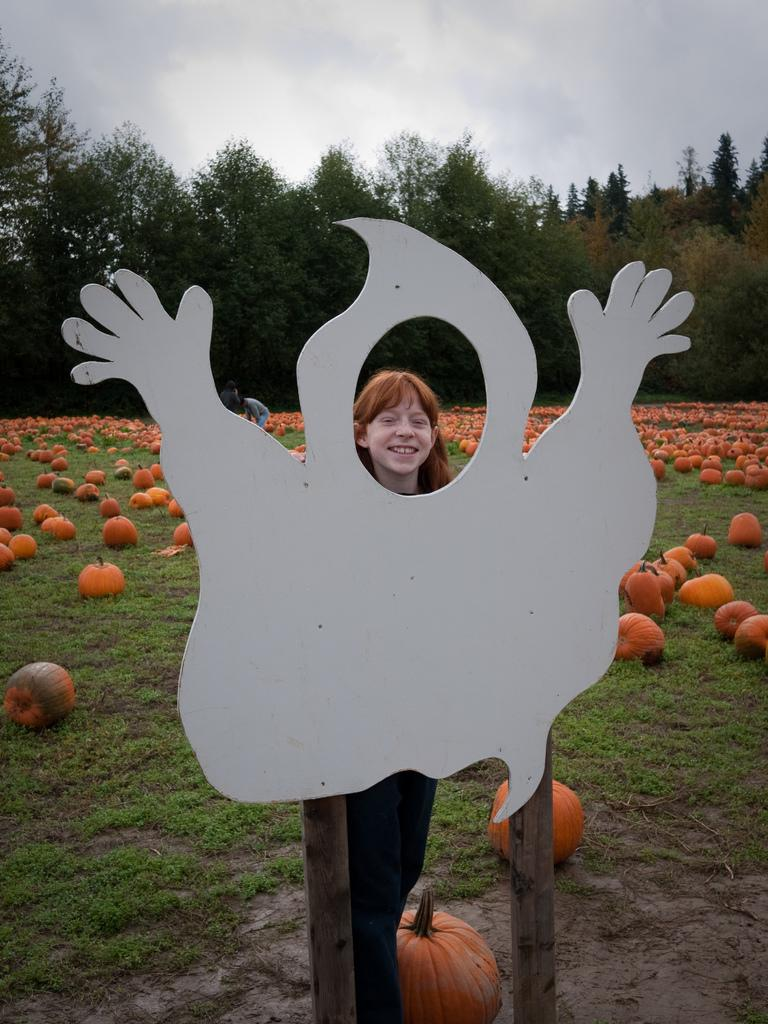Who is the main subject in the image? There is a girl in the image. What is the girl doing in the image? The girl is standing behind a cardboard toy. What can be seen on the ground in the image? There are many orange color pumpkins on the ground. What is visible in the background of the image? There are huge trees in the background of the image. What type of celery is the girl holding in the image? There is no celery present in the image; the girl is standing behind a cardboard toy. What type of camera is being used to take the picture? The facts provided do not mention a camera, so we cannot determine the type of camera used to take the picture. 